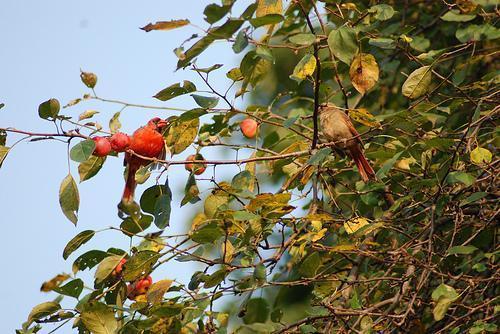How many birds are there?
Give a very brief answer. 2. 